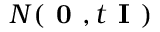<formula> <loc_0><loc_0><loc_500><loc_500>N ( 0 , t I )</formula> 